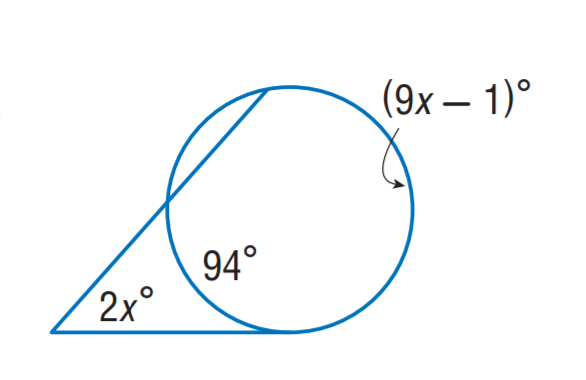Answer the mathemtical geometry problem and directly provide the correct option letter.
Question: Find x.
Choices: A: 13.5 B: 19 C: 23.5 D: 47 B 